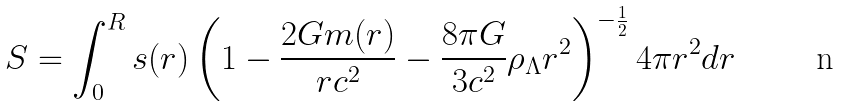<formula> <loc_0><loc_0><loc_500><loc_500>S = \int _ { 0 } ^ { R } s ( r ) \left ( 1 - \frac { 2 G m ( r ) } { r c ^ { 2 } } - \frac { 8 \pi G } { 3 c ^ { 2 } } \rho _ { \Lambda } r ^ { 2 } \right ) ^ { - \frac { 1 } { 2 } } 4 \pi r ^ { 2 } d r</formula> 